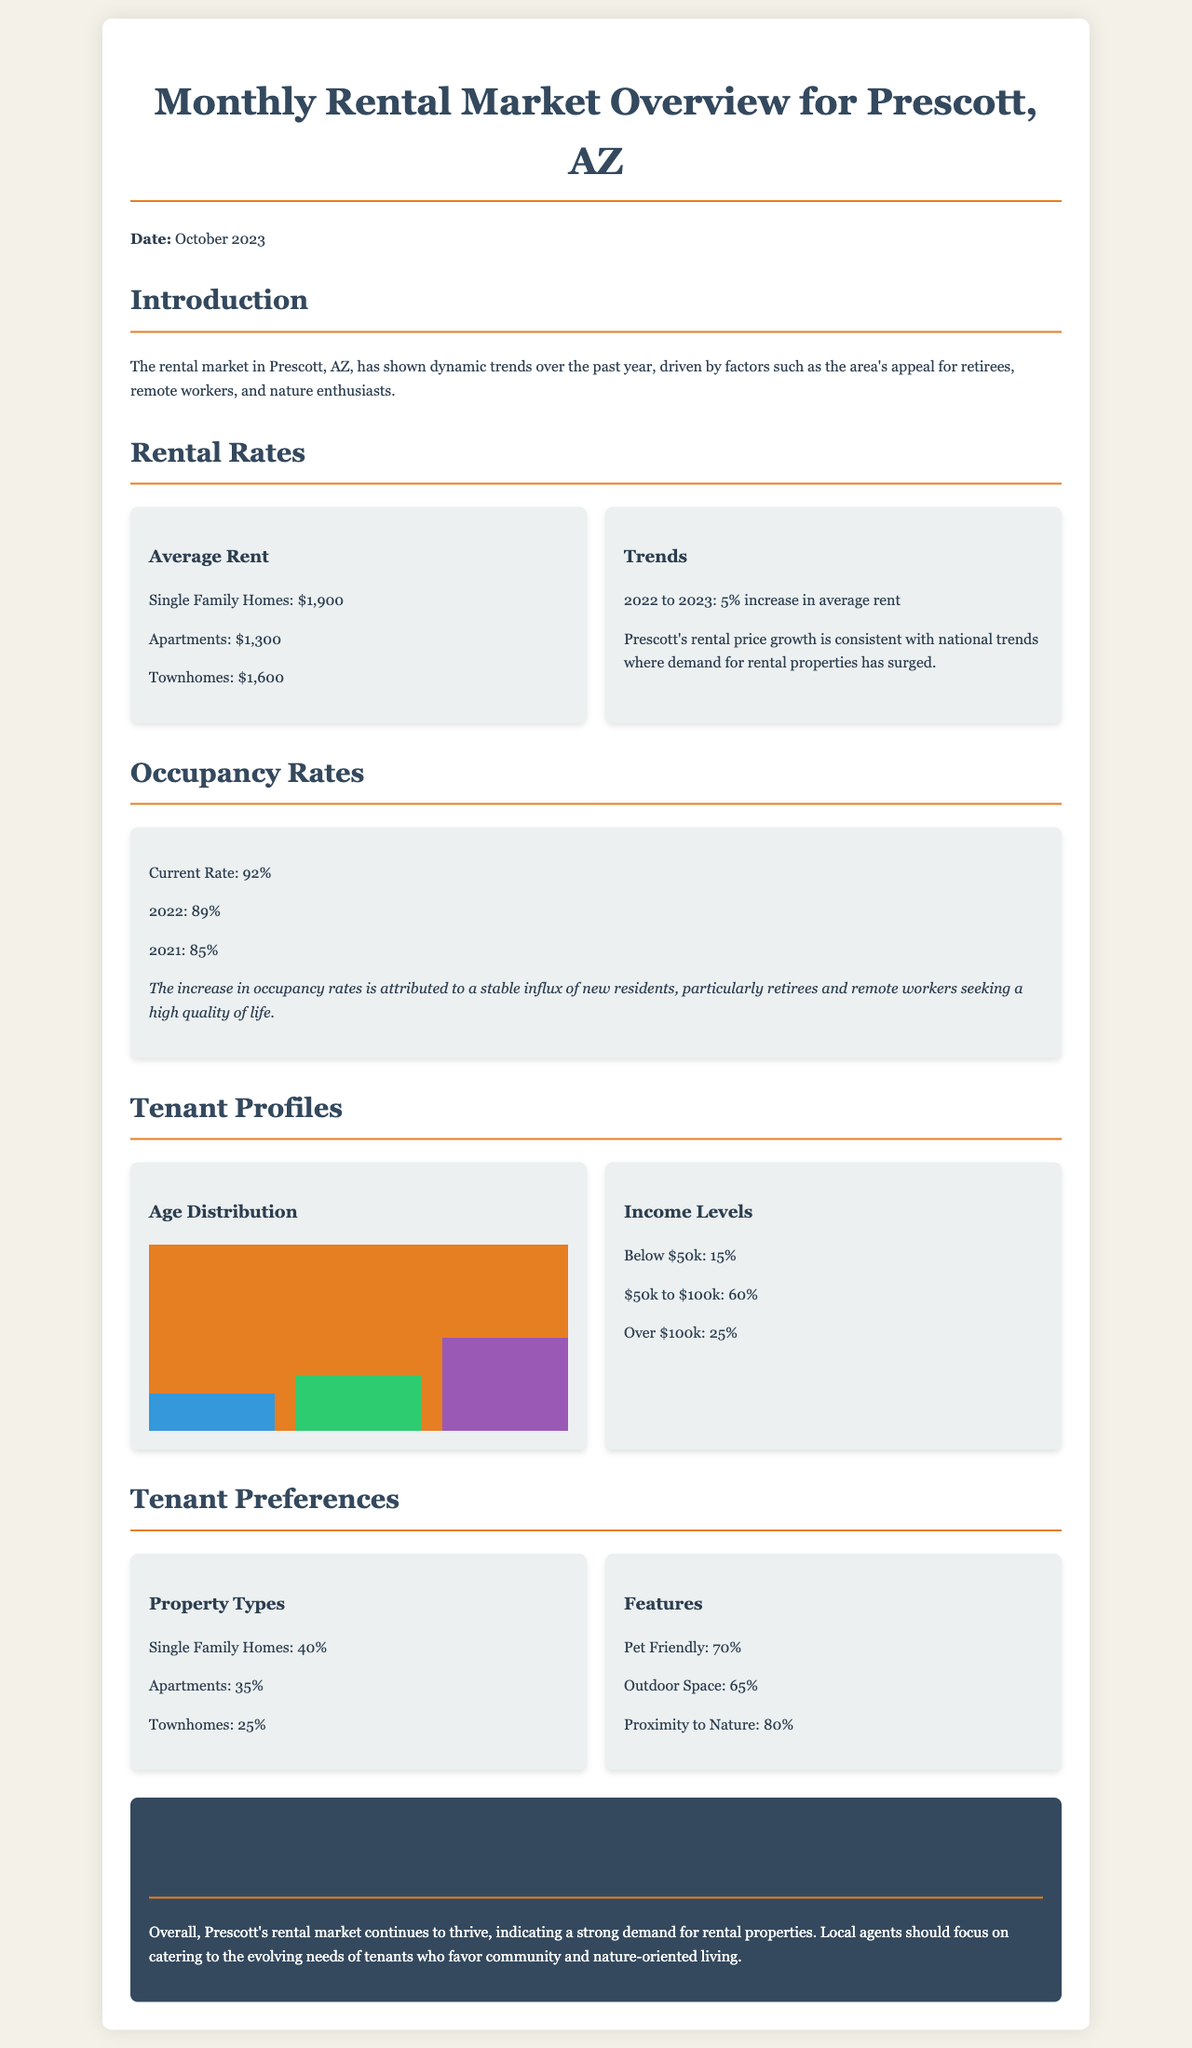what is the average rent for Single Family Homes? The document states that the average rent for Single Family Homes is $1,900.
Answer: $1,900 what was the occupancy rate in 2022? The document indicates that the occupancy rate in 2022 was 89%.
Answer: 89% what percentage of tenants earn below $50k? According to the document, 15% of tenants earn below $50k.
Answer: 15% how much has the average rent increased from 2022 to 2023? The document specifies a 5% increase in average rent from 2022 to 2023.
Answer: 5% what is the most preferred property type? The document states that the most preferred property type is Single Family Homes, with 40%.
Answer: Single Family Homes what is the current occupancy rate? The current occupancy rate in the document is stated to be 92%.
Answer: 92% what percentage of tenants prefer properties with outdoor space? The document indicates that 65% of tenants prefer properties with outdoor space.
Answer: 65% what age group has the highest representation among tenants? The document shows that the age group 55+ years has the highest representation, at 50%.
Answer: 55+ years what quality of life factors are influencing the rental market? The document mentions that new residents are primarily retirees and remote workers seeking a high quality of life.
Answer: High quality of life 